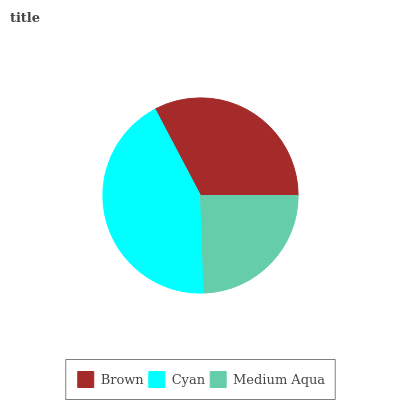Is Medium Aqua the minimum?
Answer yes or no. Yes. Is Cyan the maximum?
Answer yes or no. Yes. Is Cyan the minimum?
Answer yes or no. No. Is Medium Aqua the maximum?
Answer yes or no. No. Is Cyan greater than Medium Aqua?
Answer yes or no. Yes. Is Medium Aqua less than Cyan?
Answer yes or no. Yes. Is Medium Aqua greater than Cyan?
Answer yes or no. No. Is Cyan less than Medium Aqua?
Answer yes or no. No. Is Brown the high median?
Answer yes or no. Yes. Is Brown the low median?
Answer yes or no. Yes. Is Cyan the high median?
Answer yes or no. No. Is Cyan the low median?
Answer yes or no. No. 